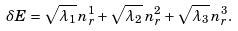Convert formula to latex. <formula><loc_0><loc_0><loc_500><loc_500>\delta E = \sqrt { \lambda _ { 1 } } \, n _ { r } ^ { 1 } + \sqrt { \lambda _ { 2 } } \, n _ { r } ^ { 2 } + \sqrt { \lambda _ { 3 } } \, n _ { r } ^ { 3 } .</formula> 